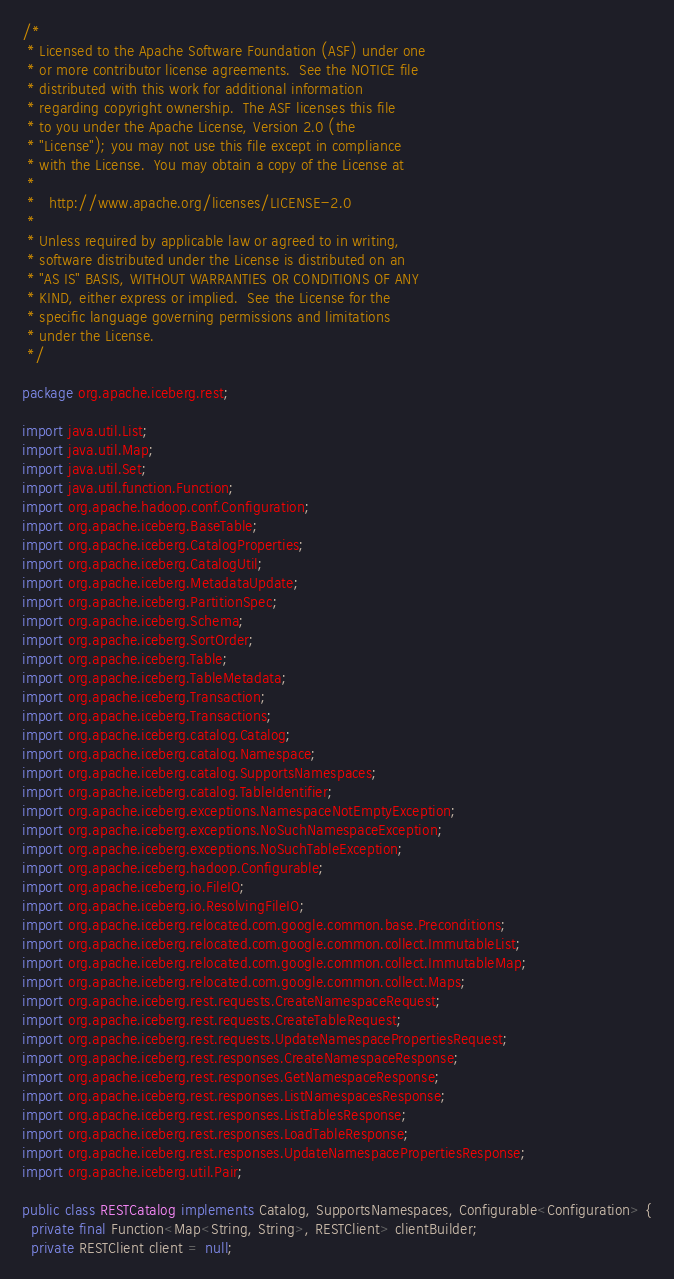Convert code to text. <code><loc_0><loc_0><loc_500><loc_500><_Java_>/*
 * Licensed to the Apache Software Foundation (ASF) under one
 * or more contributor license agreements.  See the NOTICE file
 * distributed with this work for additional information
 * regarding copyright ownership.  The ASF licenses this file
 * to you under the Apache License, Version 2.0 (the
 * "License"); you may not use this file except in compliance
 * with the License.  You may obtain a copy of the License at
 *
 *   http://www.apache.org/licenses/LICENSE-2.0
 *
 * Unless required by applicable law or agreed to in writing,
 * software distributed under the License is distributed on an
 * "AS IS" BASIS, WITHOUT WARRANTIES OR CONDITIONS OF ANY
 * KIND, either express or implied.  See the License for the
 * specific language governing permissions and limitations
 * under the License.
 */

package org.apache.iceberg.rest;

import java.util.List;
import java.util.Map;
import java.util.Set;
import java.util.function.Function;
import org.apache.hadoop.conf.Configuration;
import org.apache.iceberg.BaseTable;
import org.apache.iceberg.CatalogProperties;
import org.apache.iceberg.CatalogUtil;
import org.apache.iceberg.MetadataUpdate;
import org.apache.iceberg.PartitionSpec;
import org.apache.iceberg.Schema;
import org.apache.iceberg.SortOrder;
import org.apache.iceberg.Table;
import org.apache.iceberg.TableMetadata;
import org.apache.iceberg.Transaction;
import org.apache.iceberg.Transactions;
import org.apache.iceberg.catalog.Catalog;
import org.apache.iceberg.catalog.Namespace;
import org.apache.iceberg.catalog.SupportsNamespaces;
import org.apache.iceberg.catalog.TableIdentifier;
import org.apache.iceberg.exceptions.NamespaceNotEmptyException;
import org.apache.iceberg.exceptions.NoSuchNamespaceException;
import org.apache.iceberg.exceptions.NoSuchTableException;
import org.apache.iceberg.hadoop.Configurable;
import org.apache.iceberg.io.FileIO;
import org.apache.iceberg.io.ResolvingFileIO;
import org.apache.iceberg.relocated.com.google.common.base.Preconditions;
import org.apache.iceberg.relocated.com.google.common.collect.ImmutableList;
import org.apache.iceberg.relocated.com.google.common.collect.ImmutableMap;
import org.apache.iceberg.relocated.com.google.common.collect.Maps;
import org.apache.iceberg.rest.requests.CreateNamespaceRequest;
import org.apache.iceberg.rest.requests.CreateTableRequest;
import org.apache.iceberg.rest.requests.UpdateNamespacePropertiesRequest;
import org.apache.iceberg.rest.responses.CreateNamespaceResponse;
import org.apache.iceberg.rest.responses.GetNamespaceResponse;
import org.apache.iceberg.rest.responses.ListNamespacesResponse;
import org.apache.iceberg.rest.responses.ListTablesResponse;
import org.apache.iceberg.rest.responses.LoadTableResponse;
import org.apache.iceberg.rest.responses.UpdateNamespacePropertiesResponse;
import org.apache.iceberg.util.Pair;

public class RESTCatalog implements Catalog, SupportsNamespaces, Configurable<Configuration> {
  private final Function<Map<String, String>, RESTClient> clientBuilder;
  private RESTClient client = null;</code> 